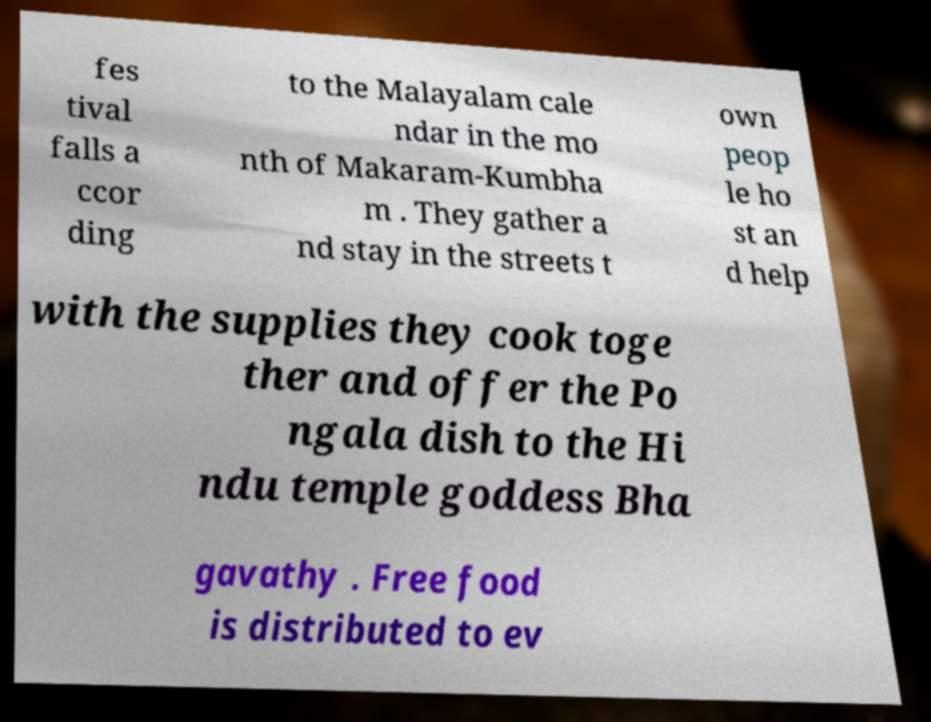Please identify and transcribe the text found in this image. fes tival falls a ccor ding to the Malayalam cale ndar in the mo nth of Makaram-Kumbha m . They gather a nd stay in the streets t own peop le ho st an d help with the supplies they cook toge ther and offer the Po ngala dish to the Hi ndu temple goddess Bha gavathy . Free food is distributed to ev 